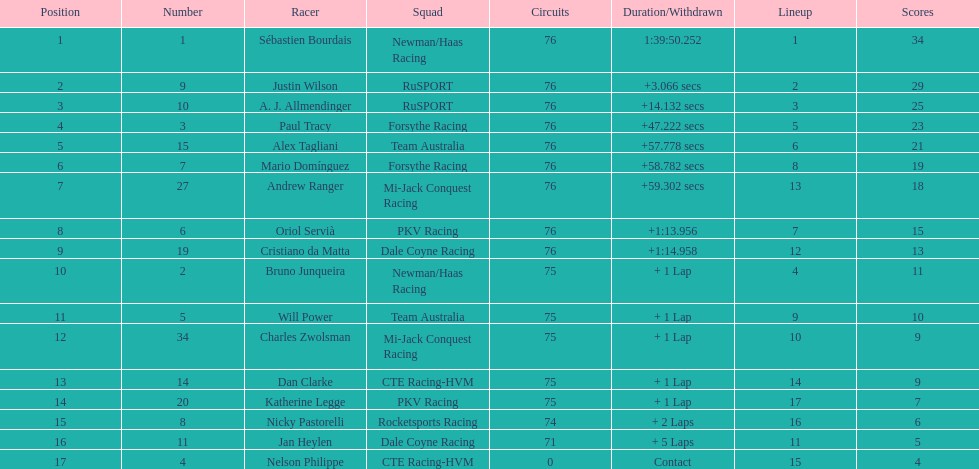How many drivers were competing for brazil? 2. 